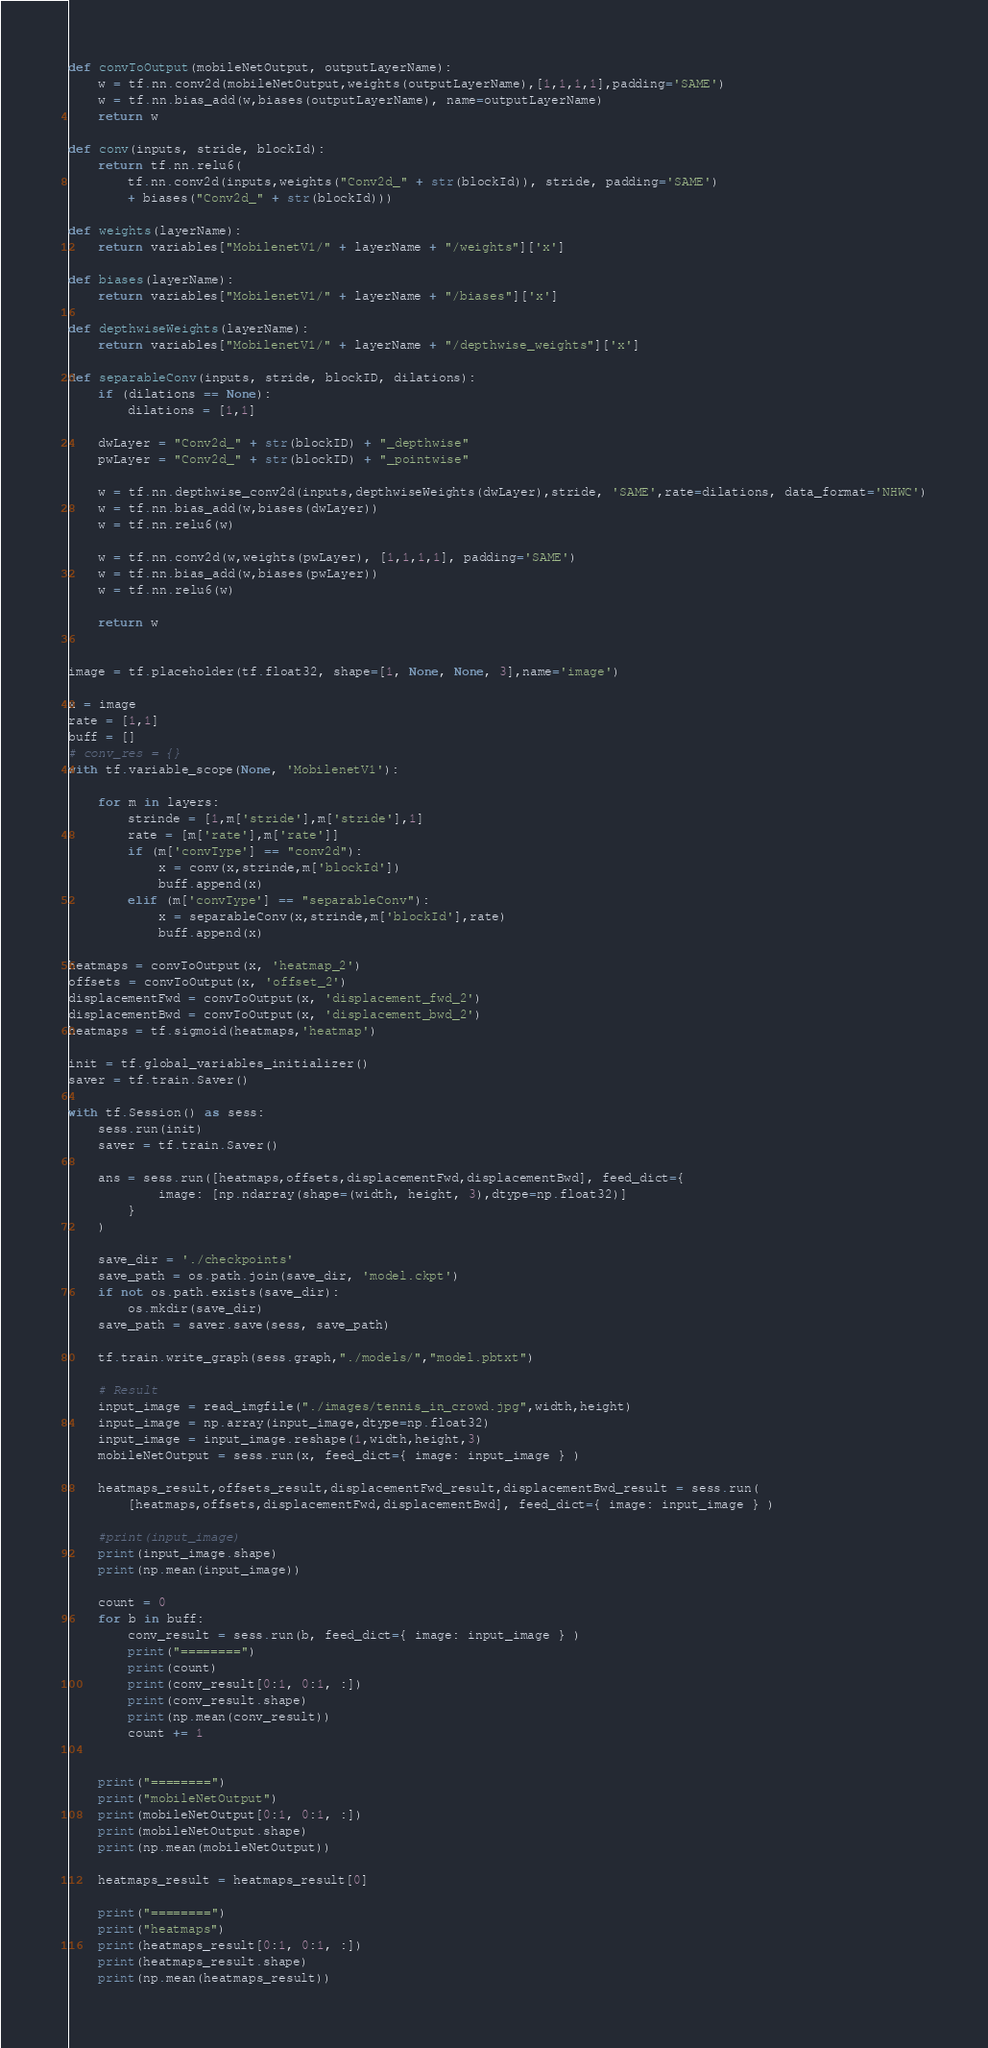<code> <loc_0><loc_0><loc_500><loc_500><_Python_>
def convToOutput(mobileNetOutput, outputLayerName):
    w = tf.nn.conv2d(mobileNetOutput,weights(outputLayerName),[1,1,1,1],padding='SAME')
    w = tf.nn.bias_add(w,biases(outputLayerName), name=outputLayerName)
    return w

def conv(inputs, stride, blockId):
    return tf.nn.relu6(
        tf.nn.conv2d(inputs,weights("Conv2d_" + str(blockId)), stride, padding='SAME') 
        + biases("Conv2d_" + str(blockId)))

def weights(layerName):
    return variables["MobilenetV1/" + layerName + "/weights"]['x']

def biases(layerName):
    return variables["MobilenetV1/" + layerName + "/biases"]['x']

def depthwiseWeights(layerName):
    return variables["MobilenetV1/" + layerName + "/depthwise_weights"]['x']

def separableConv(inputs, stride, blockID, dilations):
    if (dilations == None):
        dilations = [1,1]
    
    dwLayer = "Conv2d_" + str(blockID) + "_depthwise"
    pwLayer = "Conv2d_" + str(blockID) + "_pointwise"
    
    w = tf.nn.depthwise_conv2d(inputs,depthwiseWeights(dwLayer),stride, 'SAME',rate=dilations, data_format='NHWC')
    w = tf.nn.bias_add(w,biases(dwLayer))
    w = tf.nn.relu6(w)

    w = tf.nn.conv2d(w,weights(pwLayer), [1,1,1,1], padding='SAME')
    w = tf.nn.bias_add(w,biases(pwLayer))
    w = tf.nn.relu6(w)

    return w


image = tf.placeholder(tf.float32, shape=[1, None, None, 3],name='image')

x = image
rate = [1,1]
buff = []
# conv_res = {}
with tf.variable_scope(None, 'MobilenetV1'):
    
    for m in layers:
        strinde = [1,m['stride'],m['stride'],1]
        rate = [m['rate'],m['rate']]
        if (m['convType'] == "conv2d"):
            x = conv(x,strinde,m['blockId'])
            buff.append(x)
        elif (m['convType'] == "separableConv"):
            x = separableConv(x,strinde,m['blockId'],rate)
            buff.append(x)

heatmaps = convToOutput(x, 'heatmap_2')
offsets = convToOutput(x, 'offset_2')
displacementFwd = convToOutput(x, 'displacement_fwd_2')
displacementBwd = convToOutput(x, 'displacement_bwd_2')
heatmaps = tf.sigmoid(heatmaps,'heatmap')

init = tf.global_variables_initializer()
saver = tf.train.Saver()

with tf.Session() as sess:
    sess.run(init)
    saver = tf.train.Saver()

    ans = sess.run([heatmaps,offsets,displacementFwd,displacementBwd], feed_dict={
            image: [np.ndarray(shape=(width, height, 3),dtype=np.float32)]
        }
    )

    save_dir = './checkpoints'
    save_path = os.path.join(save_dir, 'model.ckpt')
    if not os.path.exists(save_dir):
        os.mkdir(save_dir)
    save_path = saver.save(sess, save_path)

    tf.train.write_graph(sess.graph,"./models/","model.pbtxt")

    # Result
    input_image = read_imgfile("./images/tennis_in_crowd.jpg",width,height)
    input_image = np.array(input_image,dtype=np.float32)
    input_image = input_image.reshape(1,width,height,3)
    mobileNetOutput = sess.run(x, feed_dict={ image: input_image } )

    heatmaps_result,offsets_result,displacementFwd_result,displacementBwd_result = sess.run(
        [heatmaps,offsets,displacementFwd,displacementBwd], feed_dict={ image: input_image } )

    #print(input_image)
    print(input_image.shape)
    print(np.mean(input_image))

    count = 0
    for b in buff:
        conv_result = sess.run(b, feed_dict={ image: input_image } )
        print("========")
        print(count)
        print(conv_result[0:1, 0:1, :])
        print(conv_result.shape)
        print(np.mean(conv_result))
        count += 1


    print("========")
    print("mobileNetOutput")
    print(mobileNetOutput[0:1, 0:1, :])
    print(mobileNetOutput.shape)
    print(np.mean(mobileNetOutput))
    
    heatmaps_result = heatmaps_result[0]

    print("========")
    print("heatmaps")
    print(heatmaps_result[0:1, 0:1, :])
    print(heatmaps_result.shape)
    print(np.mean(heatmaps_result))</code> 